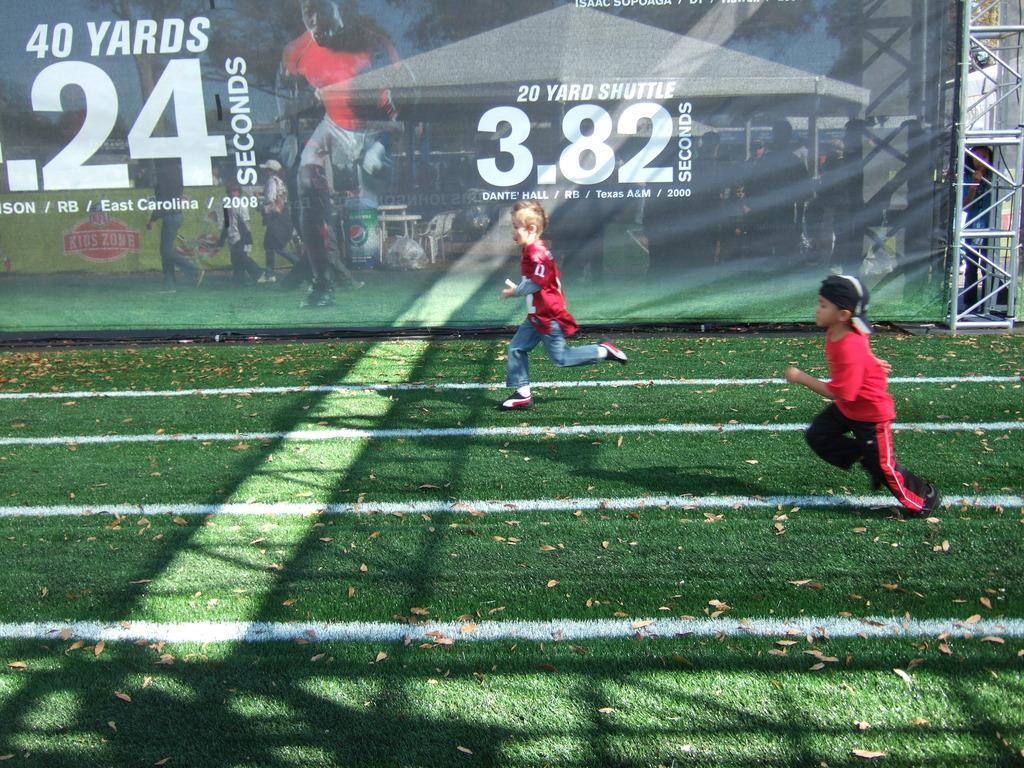Provide a one-sentence caption for the provided image. Two boys having a race with the numbers 3.82 behind them. 